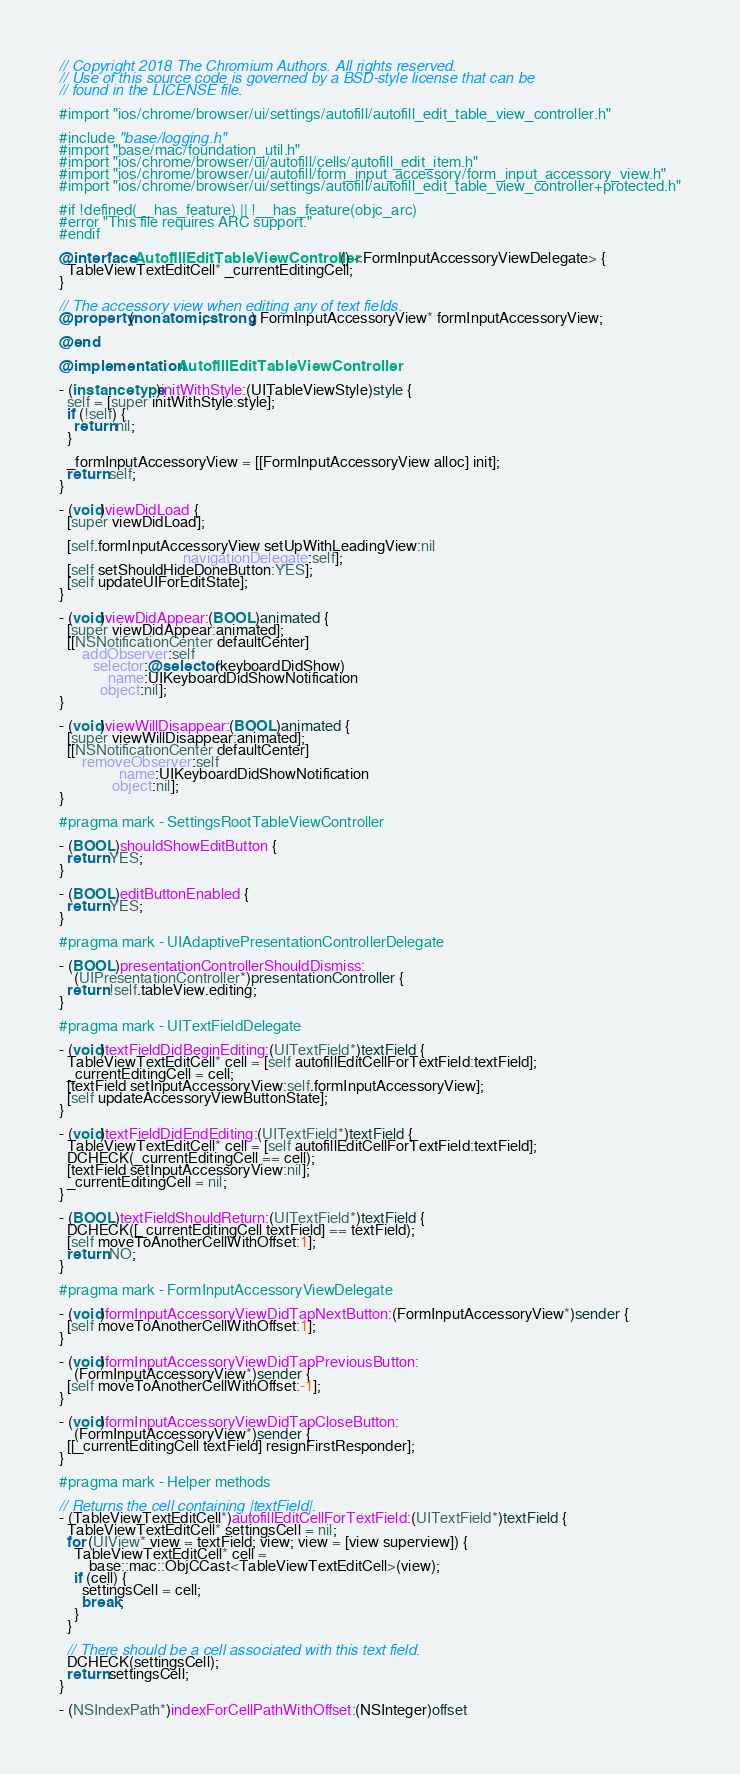<code> <loc_0><loc_0><loc_500><loc_500><_ObjectiveC_>// Copyright 2018 The Chromium Authors. All rights reserved.
// Use of this source code is governed by a BSD-style license that can be
// found in the LICENSE file.

#import "ios/chrome/browser/ui/settings/autofill/autofill_edit_table_view_controller.h"

#include "base/logging.h"
#import "base/mac/foundation_util.h"
#import "ios/chrome/browser/ui/autofill/cells/autofill_edit_item.h"
#import "ios/chrome/browser/ui/autofill/form_input_accessory/form_input_accessory_view.h"
#import "ios/chrome/browser/ui/settings/autofill/autofill_edit_table_view_controller+protected.h"

#if !defined(__has_feature) || !__has_feature(objc_arc)
#error "This file requires ARC support."
#endif

@interface AutofillEditTableViewController () <FormInputAccessoryViewDelegate> {
  TableViewTextEditCell* _currentEditingCell;
}

// The accessory view when editing any of text fields.
@property(nonatomic, strong) FormInputAccessoryView* formInputAccessoryView;

@end

@implementation AutofillEditTableViewController

- (instancetype)initWithStyle:(UITableViewStyle)style {
  self = [super initWithStyle:style];
  if (!self) {
    return nil;
  }

  _formInputAccessoryView = [[FormInputAccessoryView alloc] init];
  return self;
}

- (void)viewDidLoad {
  [super viewDidLoad];

  [self.formInputAccessoryView setUpWithLeadingView:nil
                                 navigationDelegate:self];
  [self setShouldHideDoneButton:YES];
  [self updateUIForEditState];
}

- (void)viewDidAppear:(BOOL)animated {
  [super viewDidAppear:animated];
  [[NSNotificationCenter defaultCenter]
      addObserver:self
         selector:@selector(keyboardDidShow)
             name:UIKeyboardDidShowNotification
           object:nil];
}

- (void)viewWillDisappear:(BOOL)animated {
  [super viewWillDisappear:animated];
  [[NSNotificationCenter defaultCenter]
      removeObserver:self
                name:UIKeyboardDidShowNotification
              object:nil];
}

#pragma mark - SettingsRootTableViewController

- (BOOL)shouldShowEditButton {
  return YES;
}

- (BOOL)editButtonEnabled {
  return YES;
}

#pragma mark - UIAdaptivePresentationControllerDelegate

- (BOOL)presentationControllerShouldDismiss:
    (UIPresentationController*)presentationController {
  return !self.tableView.editing;
}

#pragma mark - UITextFieldDelegate

- (void)textFieldDidBeginEditing:(UITextField*)textField {
  TableViewTextEditCell* cell = [self autofillEditCellForTextField:textField];
  _currentEditingCell = cell;
  [textField setInputAccessoryView:self.formInputAccessoryView];
  [self updateAccessoryViewButtonState];
}

- (void)textFieldDidEndEditing:(UITextField*)textField {
  TableViewTextEditCell* cell = [self autofillEditCellForTextField:textField];
  DCHECK(_currentEditingCell == cell);
  [textField setInputAccessoryView:nil];
  _currentEditingCell = nil;
}

- (BOOL)textFieldShouldReturn:(UITextField*)textField {
  DCHECK([_currentEditingCell textField] == textField);
  [self moveToAnotherCellWithOffset:1];
  return NO;
}

#pragma mark - FormInputAccessoryViewDelegate

- (void)formInputAccessoryViewDidTapNextButton:(FormInputAccessoryView*)sender {
  [self moveToAnotherCellWithOffset:1];
}

- (void)formInputAccessoryViewDidTapPreviousButton:
    (FormInputAccessoryView*)sender {
  [self moveToAnotherCellWithOffset:-1];
}

- (void)formInputAccessoryViewDidTapCloseButton:
    (FormInputAccessoryView*)sender {
  [[_currentEditingCell textField] resignFirstResponder];
}

#pragma mark - Helper methods

// Returns the cell containing |textField|.
- (TableViewTextEditCell*)autofillEditCellForTextField:(UITextField*)textField {
  TableViewTextEditCell* settingsCell = nil;
  for (UIView* view = textField; view; view = [view superview]) {
    TableViewTextEditCell* cell =
        base::mac::ObjCCast<TableViewTextEditCell>(view);
    if (cell) {
      settingsCell = cell;
      break;
    }
  }

  // There should be a cell associated with this text field.
  DCHECK(settingsCell);
  return settingsCell;
}

- (NSIndexPath*)indexForCellPathWithOffset:(NSInteger)offset</code> 